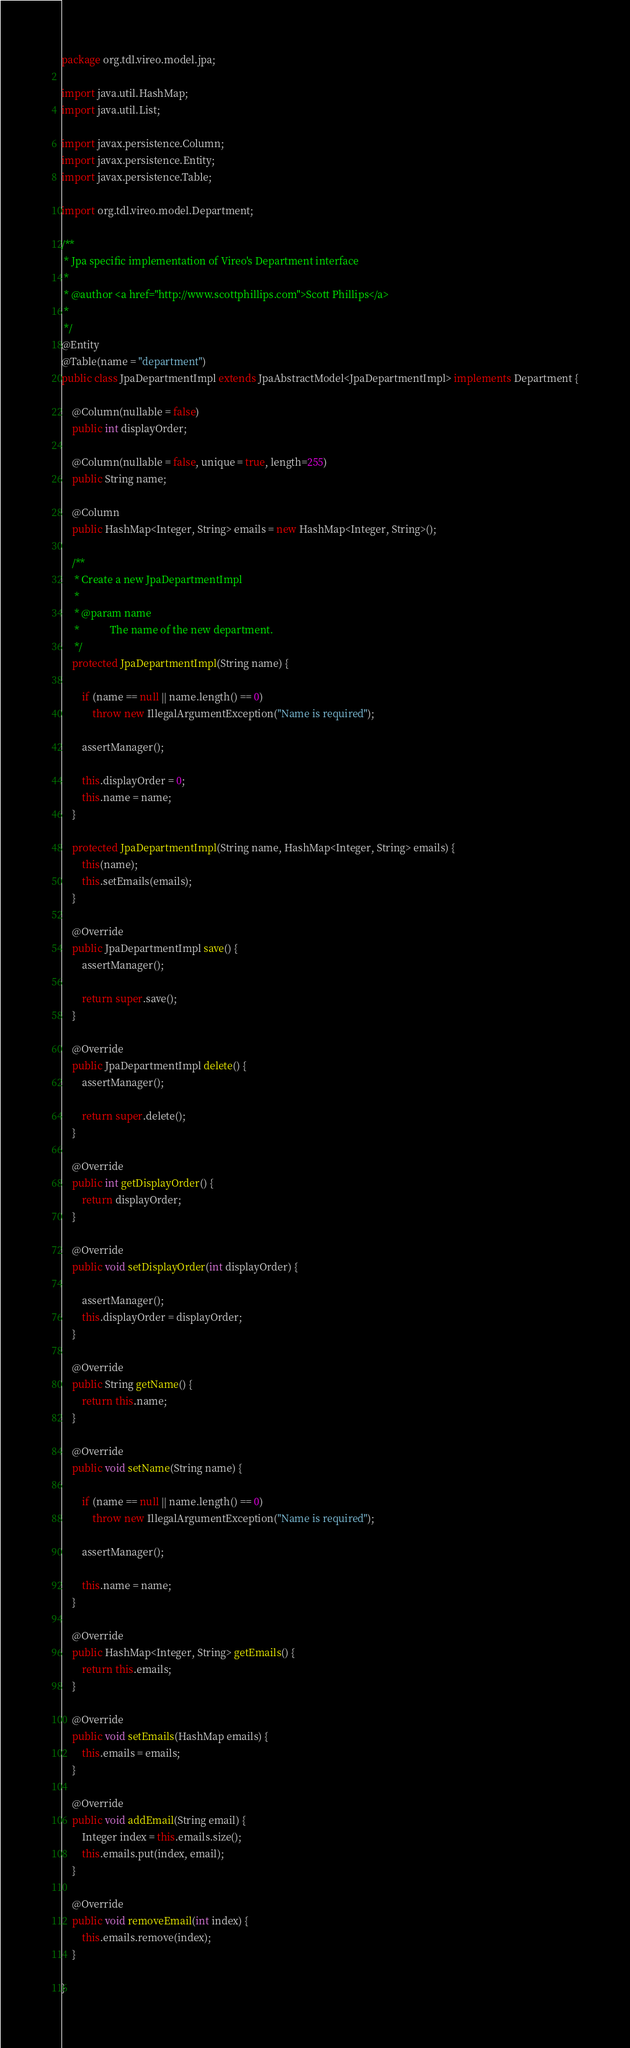<code> <loc_0><loc_0><loc_500><loc_500><_Java_>package org.tdl.vireo.model.jpa;

import java.util.HashMap;
import java.util.List;

import javax.persistence.Column;
import javax.persistence.Entity;
import javax.persistence.Table;

import org.tdl.vireo.model.Department;

/**
 * Jpa specific implementation of Vireo's Department interface
 * 
 * @author <a href="http://www.scottphillips.com">Scott Phillips</a>
 * 
 */
@Entity
@Table(name = "department")
public class JpaDepartmentImpl extends JpaAbstractModel<JpaDepartmentImpl> implements Department {

	@Column(nullable = false)
	public int displayOrder;

	@Column(nullable = false, unique = true, length=255) 
	public String name;
	
	@Column
	public HashMap<Integer, String> emails = new HashMap<Integer, String>();

	/**
	 * Create a new JpaDepartmentImpl
	 * 
	 * @param name
	 *            The name of the new department.
	 */
	protected JpaDepartmentImpl(String name) {

		if (name == null || name.length() == 0)
			throw new IllegalArgumentException("Name is required");

		assertManager();
		
		this.displayOrder = 0;
		this.name = name;
	}
	
	protected JpaDepartmentImpl(String name, HashMap<Integer, String> emails) {
		this(name);
		this.setEmails(emails);
	}
	
	@Override
	public JpaDepartmentImpl save() {
		assertManager();

		return super.save();
	}
	
	@Override
	public JpaDepartmentImpl delete() {
		assertManager();

		return super.delete();
	}

    @Override
    public int getDisplayOrder() {
        return displayOrder;
    }

    @Override
    public void setDisplayOrder(int displayOrder) {
    	
    	assertManager();
        this.displayOrder = displayOrder;
    }

	@Override
	public String getName() {
		return this.name;
	}

	@Override
	public void setName(String name) {
		
		if (name == null || name.length() == 0)
			throw new IllegalArgumentException("Name is required");
		
		assertManager();
		
		this.name = name;
	}
	
	@Override
	public HashMap<Integer, String> getEmails() {
		return this.emails;
	}

	@Override
	public void setEmails(HashMap emails) {
		this.emails = emails;
	}

	@Override
	public void addEmail(String email) {
		Integer index = this.emails.size();
		this.emails.put(index, email);
	}

	@Override
	public void removeEmail(int index) {
		this.emails.remove(index);
	}
	
}
</code> 